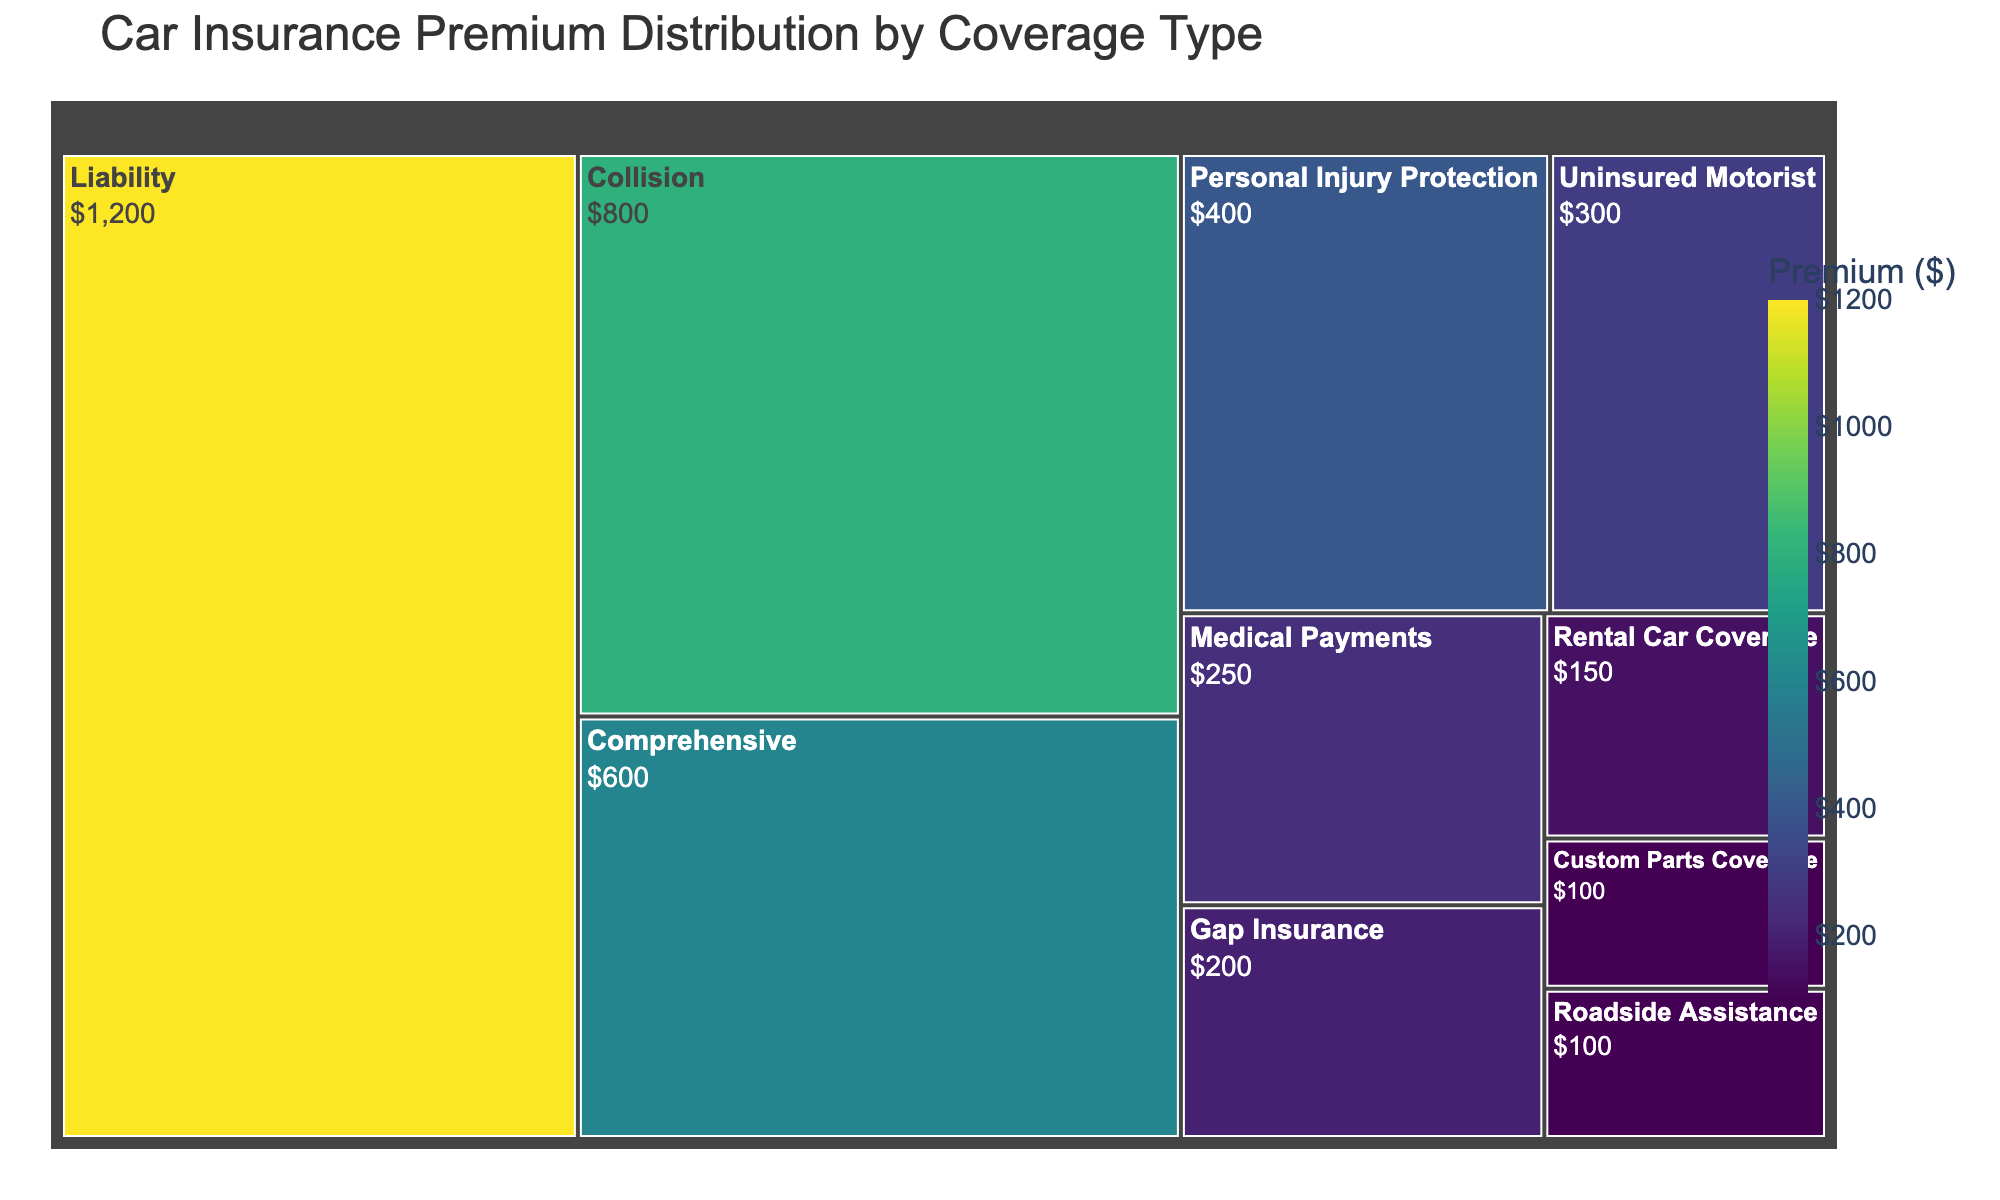What's the title of the treemap? The title of the treemap is located at the top of the figure, usually in larger font size than other text elements. It provides a brief description of the data visualization’s main theme.
Answer: Car Insurance Premium Distribution by Coverage Type What coverage type has the highest premium? To identify the coverage type with the highest premium, look for the largest rectangle in the treemap, which represents the highest value. The label on this rectangle will denote the coverage type.
Answer: Liability What is the total insurance premium across all coverage types combined? To find the total premium, sum the individual premiums of all coverage types listed in the treemap. The premiums are: 1200, 800, 600, 400, 300, 100, 150, 200, 250, 100. Adding these values gives the total.
Answer: $4100 How do the premiums for Collision and Comprehensive coverages compare? Look at the two rectangles corresponding to Collision and Comprehensive coverages. By comparing their sizes and values, you can determine which is higher. Collision has a premium of 800, and Comprehensive has a premium of 600.
Answer: Collision is higher What percentage of the total premium does Liability coverage constitute? To find this, divide the Liability premium by the total premium and multiply by 100 to convert to percentage. Liability premium is 1200 and the total premium is 4100. (1200 / 4100) * 100 ≈ 29.27%.
Answer: ~29.27% Which coverage type has the smallest premium, and what is its value? Identify the smallest rectangle in the treemap, which represents the coverage type with the lowest value. The label on this rectangle gives the coverage type and its value.
Answer: Roadside Assistance, $100 If you sum the premiums of Collision, Comprehensive, and Personal Injury Protection, what do you get? Add the premiums of Collision (800), Comprehensive (600), and Personal Injury Protection (400) together. The sum is 800 + 600 + 400.
Answer: $1800 How many coverage types have a premium of at least $200? Look for all the rectangles whose values are $200 or more. Count these rectangles. Premiums equal to or greater than $200 are for Liability, Collision, Comprehensive, Personal Injury Protection, Uninsured Motorist, Gap Insurance, and Medical Payments.
Answer: 7 What is the combined premium for all coverages less than $500? Add the premiums for coverage types that are less than $500: Personal Injury Protection (400), Uninsured Motorist (300), Roadside Assistance (100), Rental Car Coverage (150), Gap Insurance (200), Medical Payments (250), Custom Parts Coverage (100). The sum is 400 + 300 + 100 + 150 + 200 + 250 + 100.
Answer: $1500 Which coverage type is closest to the average premium value, and what is that average? First, calculate the average premium by dividing the total premium by the number of coverage types: $4100 / 10 = $410. Next, find the coverage type with a premium value closest to $410 by comparing the absolute differences. Personal Injury Protection (400) is closest to 410.
Answer: Personal Injury Protection, $410 